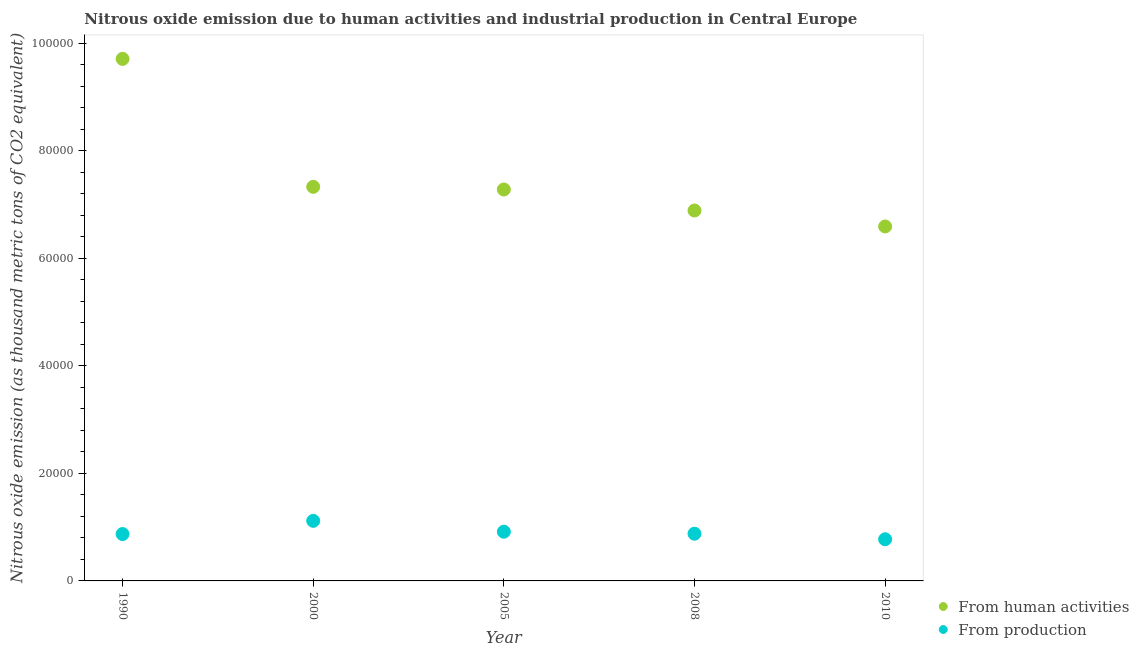How many different coloured dotlines are there?
Your answer should be very brief. 2. What is the amount of emissions generated from industries in 2008?
Offer a terse response. 8781. Across all years, what is the maximum amount of emissions generated from industries?
Provide a short and direct response. 1.12e+04. Across all years, what is the minimum amount of emissions generated from industries?
Provide a succinct answer. 7749.3. In which year was the amount of emissions from human activities minimum?
Your answer should be compact. 2010. What is the total amount of emissions generated from industries in the graph?
Provide a short and direct response. 4.56e+04. What is the difference between the amount of emissions from human activities in 2005 and that in 2008?
Your answer should be compact. 3910.3. What is the difference between the amount of emissions from human activities in 2000 and the amount of emissions generated from industries in 2008?
Make the answer very short. 6.45e+04. What is the average amount of emissions from human activities per year?
Your response must be concise. 7.56e+04. In the year 2008, what is the difference between the amount of emissions generated from industries and amount of emissions from human activities?
Your response must be concise. -6.01e+04. In how many years, is the amount of emissions from human activities greater than 36000 thousand metric tons?
Your answer should be compact. 5. What is the ratio of the amount of emissions from human activities in 1990 to that in 2005?
Make the answer very short. 1.33. Is the difference between the amount of emissions generated from industries in 2000 and 2010 greater than the difference between the amount of emissions from human activities in 2000 and 2010?
Provide a short and direct response. No. What is the difference between the highest and the second highest amount of emissions generated from industries?
Your answer should be very brief. 2021.6. What is the difference between the highest and the lowest amount of emissions generated from industries?
Your response must be concise. 3426.9. Is the sum of the amount of emissions generated from industries in 2000 and 2005 greater than the maximum amount of emissions from human activities across all years?
Make the answer very short. No. Does the amount of emissions generated from industries monotonically increase over the years?
Offer a terse response. No. Is the amount of emissions generated from industries strictly greater than the amount of emissions from human activities over the years?
Offer a terse response. No. Is the amount of emissions generated from industries strictly less than the amount of emissions from human activities over the years?
Provide a succinct answer. Yes. How many years are there in the graph?
Make the answer very short. 5. What is the difference between two consecutive major ticks on the Y-axis?
Your answer should be compact. 2.00e+04. Does the graph contain any zero values?
Make the answer very short. No. How many legend labels are there?
Provide a short and direct response. 2. How are the legend labels stacked?
Your answer should be compact. Vertical. What is the title of the graph?
Your response must be concise. Nitrous oxide emission due to human activities and industrial production in Central Europe. Does "Nitrous oxide emissions" appear as one of the legend labels in the graph?
Keep it short and to the point. No. What is the label or title of the X-axis?
Make the answer very short. Year. What is the label or title of the Y-axis?
Make the answer very short. Nitrous oxide emission (as thousand metric tons of CO2 equivalent). What is the Nitrous oxide emission (as thousand metric tons of CO2 equivalent) of From human activities in 1990?
Your answer should be very brief. 9.71e+04. What is the Nitrous oxide emission (as thousand metric tons of CO2 equivalent) in From production in 1990?
Your response must be concise. 8719. What is the Nitrous oxide emission (as thousand metric tons of CO2 equivalent) of From human activities in 2000?
Provide a succinct answer. 7.33e+04. What is the Nitrous oxide emission (as thousand metric tons of CO2 equivalent) in From production in 2000?
Keep it short and to the point. 1.12e+04. What is the Nitrous oxide emission (as thousand metric tons of CO2 equivalent) of From human activities in 2005?
Offer a terse response. 7.28e+04. What is the Nitrous oxide emission (as thousand metric tons of CO2 equivalent) in From production in 2005?
Offer a very short reply. 9154.6. What is the Nitrous oxide emission (as thousand metric tons of CO2 equivalent) in From human activities in 2008?
Your answer should be very brief. 6.89e+04. What is the Nitrous oxide emission (as thousand metric tons of CO2 equivalent) of From production in 2008?
Offer a very short reply. 8781. What is the Nitrous oxide emission (as thousand metric tons of CO2 equivalent) of From human activities in 2010?
Your answer should be compact. 6.59e+04. What is the Nitrous oxide emission (as thousand metric tons of CO2 equivalent) in From production in 2010?
Make the answer very short. 7749.3. Across all years, what is the maximum Nitrous oxide emission (as thousand metric tons of CO2 equivalent) of From human activities?
Offer a very short reply. 9.71e+04. Across all years, what is the maximum Nitrous oxide emission (as thousand metric tons of CO2 equivalent) of From production?
Your answer should be very brief. 1.12e+04. Across all years, what is the minimum Nitrous oxide emission (as thousand metric tons of CO2 equivalent) in From human activities?
Offer a terse response. 6.59e+04. Across all years, what is the minimum Nitrous oxide emission (as thousand metric tons of CO2 equivalent) of From production?
Offer a very short reply. 7749.3. What is the total Nitrous oxide emission (as thousand metric tons of CO2 equivalent) of From human activities in the graph?
Your answer should be very brief. 3.78e+05. What is the total Nitrous oxide emission (as thousand metric tons of CO2 equivalent) of From production in the graph?
Offer a very short reply. 4.56e+04. What is the difference between the Nitrous oxide emission (as thousand metric tons of CO2 equivalent) of From human activities in 1990 and that in 2000?
Give a very brief answer. 2.38e+04. What is the difference between the Nitrous oxide emission (as thousand metric tons of CO2 equivalent) of From production in 1990 and that in 2000?
Offer a very short reply. -2457.2. What is the difference between the Nitrous oxide emission (as thousand metric tons of CO2 equivalent) in From human activities in 1990 and that in 2005?
Your response must be concise. 2.43e+04. What is the difference between the Nitrous oxide emission (as thousand metric tons of CO2 equivalent) in From production in 1990 and that in 2005?
Give a very brief answer. -435.6. What is the difference between the Nitrous oxide emission (as thousand metric tons of CO2 equivalent) in From human activities in 1990 and that in 2008?
Offer a very short reply. 2.82e+04. What is the difference between the Nitrous oxide emission (as thousand metric tons of CO2 equivalent) in From production in 1990 and that in 2008?
Provide a short and direct response. -62. What is the difference between the Nitrous oxide emission (as thousand metric tons of CO2 equivalent) in From human activities in 1990 and that in 2010?
Offer a very short reply. 3.12e+04. What is the difference between the Nitrous oxide emission (as thousand metric tons of CO2 equivalent) in From production in 1990 and that in 2010?
Provide a short and direct response. 969.7. What is the difference between the Nitrous oxide emission (as thousand metric tons of CO2 equivalent) in From human activities in 2000 and that in 2005?
Provide a short and direct response. 496.7. What is the difference between the Nitrous oxide emission (as thousand metric tons of CO2 equivalent) of From production in 2000 and that in 2005?
Give a very brief answer. 2021.6. What is the difference between the Nitrous oxide emission (as thousand metric tons of CO2 equivalent) of From human activities in 2000 and that in 2008?
Your answer should be very brief. 4407. What is the difference between the Nitrous oxide emission (as thousand metric tons of CO2 equivalent) of From production in 2000 and that in 2008?
Provide a short and direct response. 2395.2. What is the difference between the Nitrous oxide emission (as thousand metric tons of CO2 equivalent) of From human activities in 2000 and that in 2010?
Make the answer very short. 7373.8. What is the difference between the Nitrous oxide emission (as thousand metric tons of CO2 equivalent) in From production in 2000 and that in 2010?
Your answer should be very brief. 3426.9. What is the difference between the Nitrous oxide emission (as thousand metric tons of CO2 equivalent) in From human activities in 2005 and that in 2008?
Provide a succinct answer. 3910.3. What is the difference between the Nitrous oxide emission (as thousand metric tons of CO2 equivalent) in From production in 2005 and that in 2008?
Your response must be concise. 373.6. What is the difference between the Nitrous oxide emission (as thousand metric tons of CO2 equivalent) in From human activities in 2005 and that in 2010?
Ensure brevity in your answer.  6877.1. What is the difference between the Nitrous oxide emission (as thousand metric tons of CO2 equivalent) in From production in 2005 and that in 2010?
Offer a terse response. 1405.3. What is the difference between the Nitrous oxide emission (as thousand metric tons of CO2 equivalent) in From human activities in 2008 and that in 2010?
Your answer should be compact. 2966.8. What is the difference between the Nitrous oxide emission (as thousand metric tons of CO2 equivalent) in From production in 2008 and that in 2010?
Provide a short and direct response. 1031.7. What is the difference between the Nitrous oxide emission (as thousand metric tons of CO2 equivalent) of From human activities in 1990 and the Nitrous oxide emission (as thousand metric tons of CO2 equivalent) of From production in 2000?
Your answer should be compact. 8.59e+04. What is the difference between the Nitrous oxide emission (as thousand metric tons of CO2 equivalent) in From human activities in 1990 and the Nitrous oxide emission (as thousand metric tons of CO2 equivalent) in From production in 2005?
Give a very brief answer. 8.80e+04. What is the difference between the Nitrous oxide emission (as thousand metric tons of CO2 equivalent) in From human activities in 1990 and the Nitrous oxide emission (as thousand metric tons of CO2 equivalent) in From production in 2008?
Your answer should be very brief. 8.83e+04. What is the difference between the Nitrous oxide emission (as thousand metric tons of CO2 equivalent) of From human activities in 1990 and the Nitrous oxide emission (as thousand metric tons of CO2 equivalent) of From production in 2010?
Offer a terse response. 8.94e+04. What is the difference between the Nitrous oxide emission (as thousand metric tons of CO2 equivalent) of From human activities in 2000 and the Nitrous oxide emission (as thousand metric tons of CO2 equivalent) of From production in 2005?
Offer a very short reply. 6.42e+04. What is the difference between the Nitrous oxide emission (as thousand metric tons of CO2 equivalent) of From human activities in 2000 and the Nitrous oxide emission (as thousand metric tons of CO2 equivalent) of From production in 2008?
Offer a very short reply. 6.45e+04. What is the difference between the Nitrous oxide emission (as thousand metric tons of CO2 equivalent) in From human activities in 2000 and the Nitrous oxide emission (as thousand metric tons of CO2 equivalent) in From production in 2010?
Make the answer very short. 6.56e+04. What is the difference between the Nitrous oxide emission (as thousand metric tons of CO2 equivalent) of From human activities in 2005 and the Nitrous oxide emission (as thousand metric tons of CO2 equivalent) of From production in 2008?
Your response must be concise. 6.40e+04. What is the difference between the Nitrous oxide emission (as thousand metric tons of CO2 equivalent) of From human activities in 2005 and the Nitrous oxide emission (as thousand metric tons of CO2 equivalent) of From production in 2010?
Your answer should be very brief. 6.51e+04. What is the difference between the Nitrous oxide emission (as thousand metric tons of CO2 equivalent) of From human activities in 2008 and the Nitrous oxide emission (as thousand metric tons of CO2 equivalent) of From production in 2010?
Ensure brevity in your answer.  6.12e+04. What is the average Nitrous oxide emission (as thousand metric tons of CO2 equivalent) in From human activities per year?
Make the answer very short. 7.56e+04. What is the average Nitrous oxide emission (as thousand metric tons of CO2 equivalent) of From production per year?
Give a very brief answer. 9116.02. In the year 1990, what is the difference between the Nitrous oxide emission (as thousand metric tons of CO2 equivalent) of From human activities and Nitrous oxide emission (as thousand metric tons of CO2 equivalent) of From production?
Keep it short and to the point. 8.84e+04. In the year 2000, what is the difference between the Nitrous oxide emission (as thousand metric tons of CO2 equivalent) in From human activities and Nitrous oxide emission (as thousand metric tons of CO2 equivalent) in From production?
Make the answer very short. 6.21e+04. In the year 2005, what is the difference between the Nitrous oxide emission (as thousand metric tons of CO2 equivalent) in From human activities and Nitrous oxide emission (as thousand metric tons of CO2 equivalent) in From production?
Your response must be concise. 6.37e+04. In the year 2008, what is the difference between the Nitrous oxide emission (as thousand metric tons of CO2 equivalent) in From human activities and Nitrous oxide emission (as thousand metric tons of CO2 equivalent) in From production?
Keep it short and to the point. 6.01e+04. In the year 2010, what is the difference between the Nitrous oxide emission (as thousand metric tons of CO2 equivalent) of From human activities and Nitrous oxide emission (as thousand metric tons of CO2 equivalent) of From production?
Provide a succinct answer. 5.82e+04. What is the ratio of the Nitrous oxide emission (as thousand metric tons of CO2 equivalent) of From human activities in 1990 to that in 2000?
Give a very brief answer. 1.32. What is the ratio of the Nitrous oxide emission (as thousand metric tons of CO2 equivalent) in From production in 1990 to that in 2000?
Offer a very short reply. 0.78. What is the ratio of the Nitrous oxide emission (as thousand metric tons of CO2 equivalent) of From human activities in 1990 to that in 2005?
Offer a terse response. 1.33. What is the ratio of the Nitrous oxide emission (as thousand metric tons of CO2 equivalent) in From human activities in 1990 to that in 2008?
Make the answer very short. 1.41. What is the ratio of the Nitrous oxide emission (as thousand metric tons of CO2 equivalent) of From production in 1990 to that in 2008?
Provide a short and direct response. 0.99. What is the ratio of the Nitrous oxide emission (as thousand metric tons of CO2 equivalent) in From human activities in 1990 to that in 2010?
Your response must be concise. 1.47. What is the ratio of the Nitrous oxide emission (as thousand metric tons of CO2 equivalent) of From production in 1990 to that in 2010?
Your answer should be very brief. 1.13. What is the ratio of the Nitrous oxide emission (as thousand metric tons of CO2 equivalent) in From human activities in 2000 to that in 2005?
Give a very brief answer. 1.01. What is the ratio of the Nitrous oxide emission (as thousand metric tons of CO2 equivalent) in From production in 2000 to that in 2005?
Provide a succinct answer. 1.22. What is the ratio of the Nitrous oxide emission (as thousand metric tons of CO2 equivalent) of From human activities in 2000 to that in 2008?
Give a very brief answer. 1.06. What is the ratio of the Nitrous oxide emission (as thousand metric tons of CO2 equivalent) of From production in 2000 to that in 2008?
Your answer should be compact. 1.27. What is the ratio of the Nitrous oxide emission (as thousand metric tons of CO2 equivalent) in From human activities in 2000 to that in 2010?
Your answer should be compact. 1.11. What is the ratio of the Nitrous oxide emission (as thousand metric tons of CO2 equivalent) in From production in 2000 to that in 2010?
Offer a terse response. 1.44. What is the ratio of the Nitrous oxide emission (as thousand metric tons of CO2 equivalent) in From human activities in 2005 to that in 2008?
Provide a short and direct response. 1.06. What is the ratio of the Nitrous oxide emission (as thousand metric tons of CO2 equivalent) of From production in 2005 to that in 2008?
Offer a very short reply. 1.04. What is the ratio of the Nitrous oxide emission (as thousand metric tons of CO2 equivalent) in From human activities in 2005 to that in 2010?
Offer a very short reply. 1.1. What is the ratio of the Nitrous oxide emission (as thousand metric tons of CO2 equivalent) in From production in 2005 to that in 2010?
Offer a very short reply. 1.18. What is the ratio of the Nitrous oxide emission (as thousand metric tons of CO2 equivalent) of From human activities in 2008 to that in 2010?
Make the answer very short. 1.04. What is the ratio of the Nitrous oxide emission (as thousand metric tons of CO2 equivalent) in From production in 2008 to that in 2010?
Your answer should be very brief. 1.13. What is the difference between the highest and the second highest Nitrous oxide emission (as thousand metric tons of CO2 equivalent) of From human activities?
Make the answer very short. 2.38e+04. What is the difference between the highest and the second highest Nitrous oxide emission (as thousand metric tons of CO2 equivalent) in From production?
Give a very brief answer. 2021.6. What is the difference between the highest and the lowest Nitrous oxide emission (as thousand metric tons of CO2 equivalent) of From human activities?
Your response must be concise. 3.12e+04. What is the difference between the highest and the lowest Nitrous oxide emission (as thousand metric tons of CO2 equivalent) in From production?
Offer a terse response. 3426.9. 